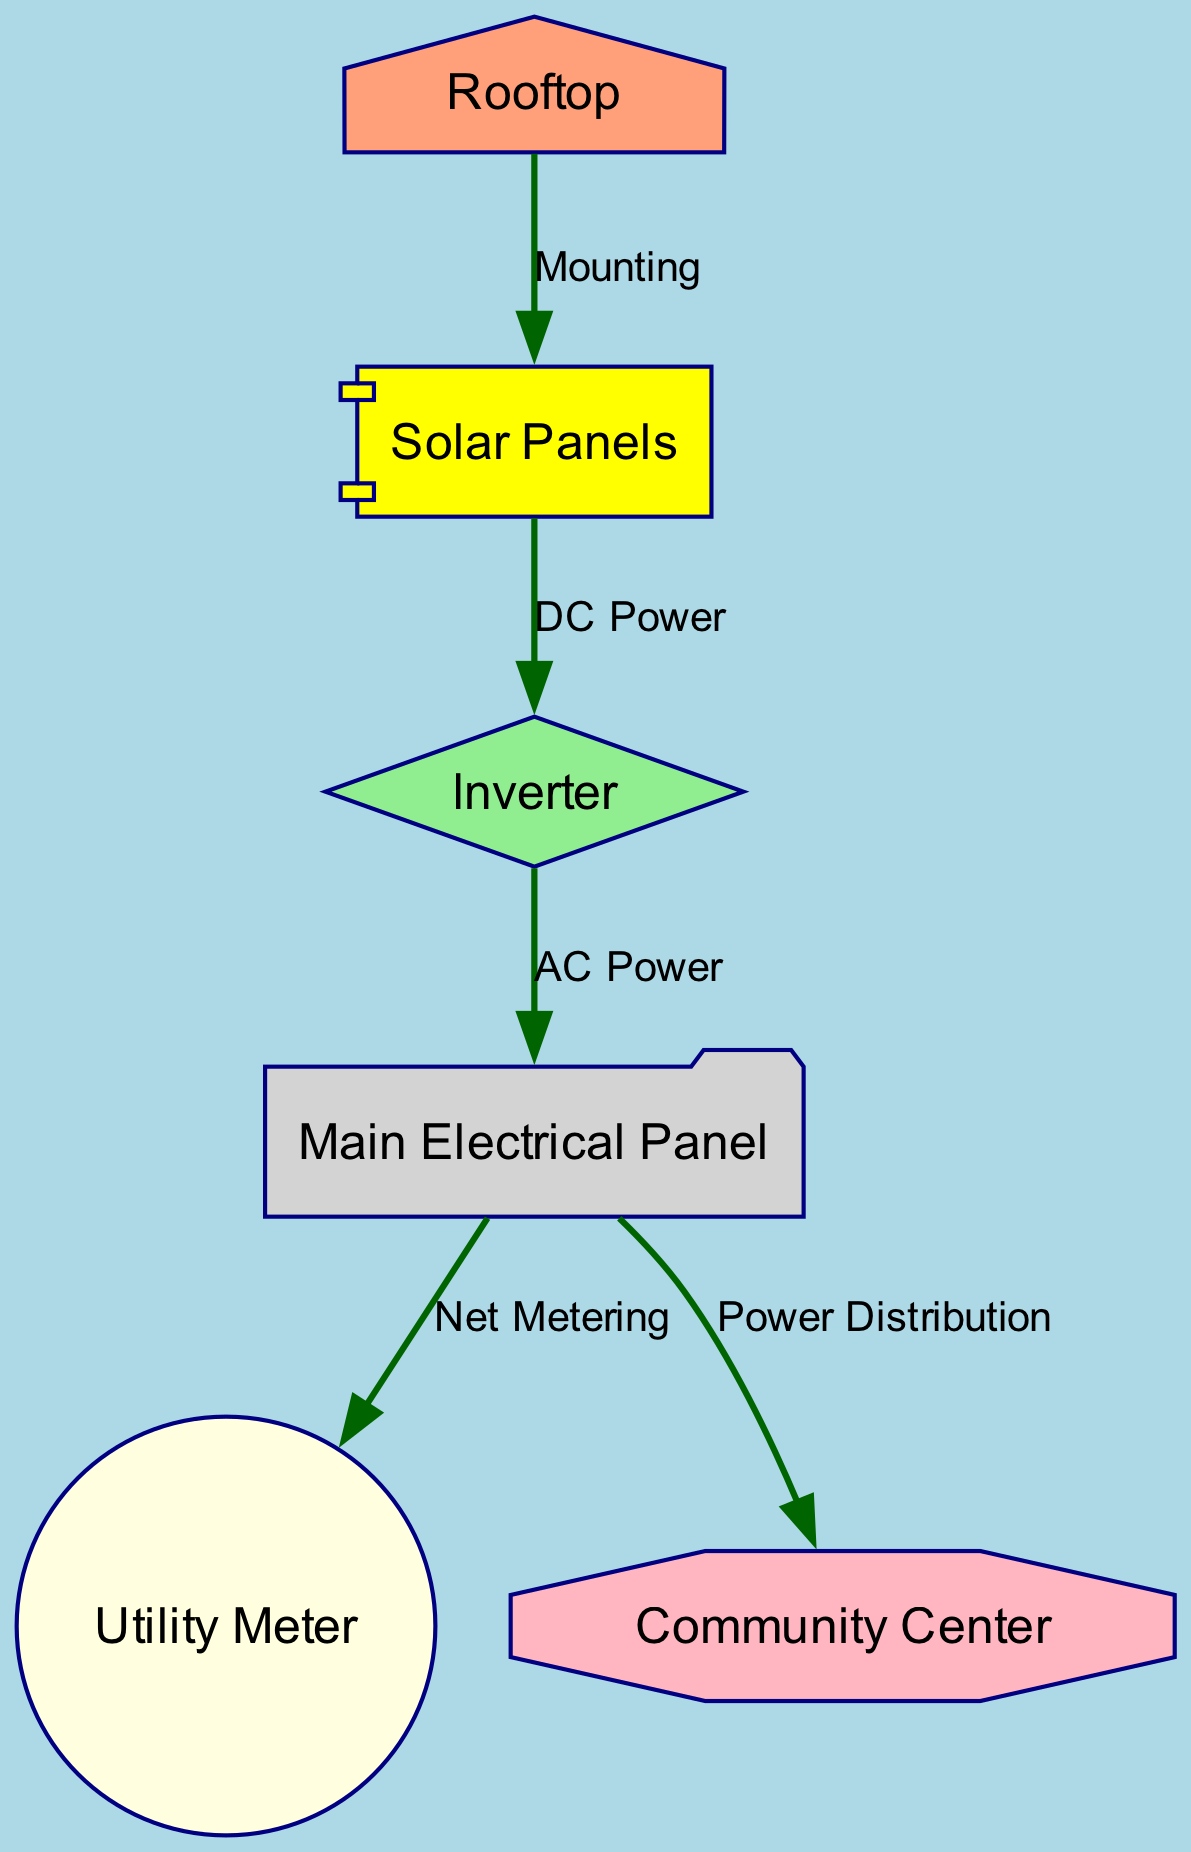What is the main component placed on the rooftop? The diagram indicates that the "Solar Panels" are mounted on the "Rooftop." This is the only connection showing mounting on this specific node.
Answer: Solar Panels How many nodes are in this diagram? By counting the individual components shown within the diagram, we can identify a total of six distinct nodes. They include Rooftop, Solar Panels, Inverter, Main Electrical Panel, Utility Meter, and Community Center.
Answer: 6 What type of connection exists between Solar Panels and Inverter? The diagram shows a direct line labeled "DC Power" connecting "Solar Panels" to "Inverter." This indicates the transfer of direct current electrical power.
Answer: DC Power How is power distributed from the Main Electrical Panel? According to the diagram, the "Main Electrical Panel" has two outgoing connections; one goes to the "Utility Meter" labeled "Net Metering," and the other goes to the "Community Center" labeled "Power Distribution." This indicates that power is split to these two destinations.
Answer: Utility Meter and Community Center Which component is associated with net metering? The "Utility Meter" node is directly linked to the "Main Electrical Panel" via the connection labeled "Net Metering," indicating its role in monitoring the net power flow.
Answer: Utility Meter How many edges are depicted in the diagram? By analyzing the connections between the nodes, we can count a total of five edges. Each edge represents a relationship between two components in the solar panel system schematic.
Answer: 5 What shape represents the Community Center in the diagram? The "Community Center" is illustrated as a shape of an octagon in the diagram. This specific shape distinguishes it from other components visually.
Answer: Octagon What type of component is the Inverter? The "Inverter" in the diagram is represented as a diamond shape, indicating its function as a critical component in converting DC power to AC power.
Answer: Diamond How does power flow from the Solar Panels? The power flows from "Solar Panels" to "Inverter," which converts the DC power to AC power; this AC power then flows to the "Main Electrical Panel." This flow sequence indicates the transformation and distribution process of solar energy.
Answer: Inverter to Main Electrical Panel 